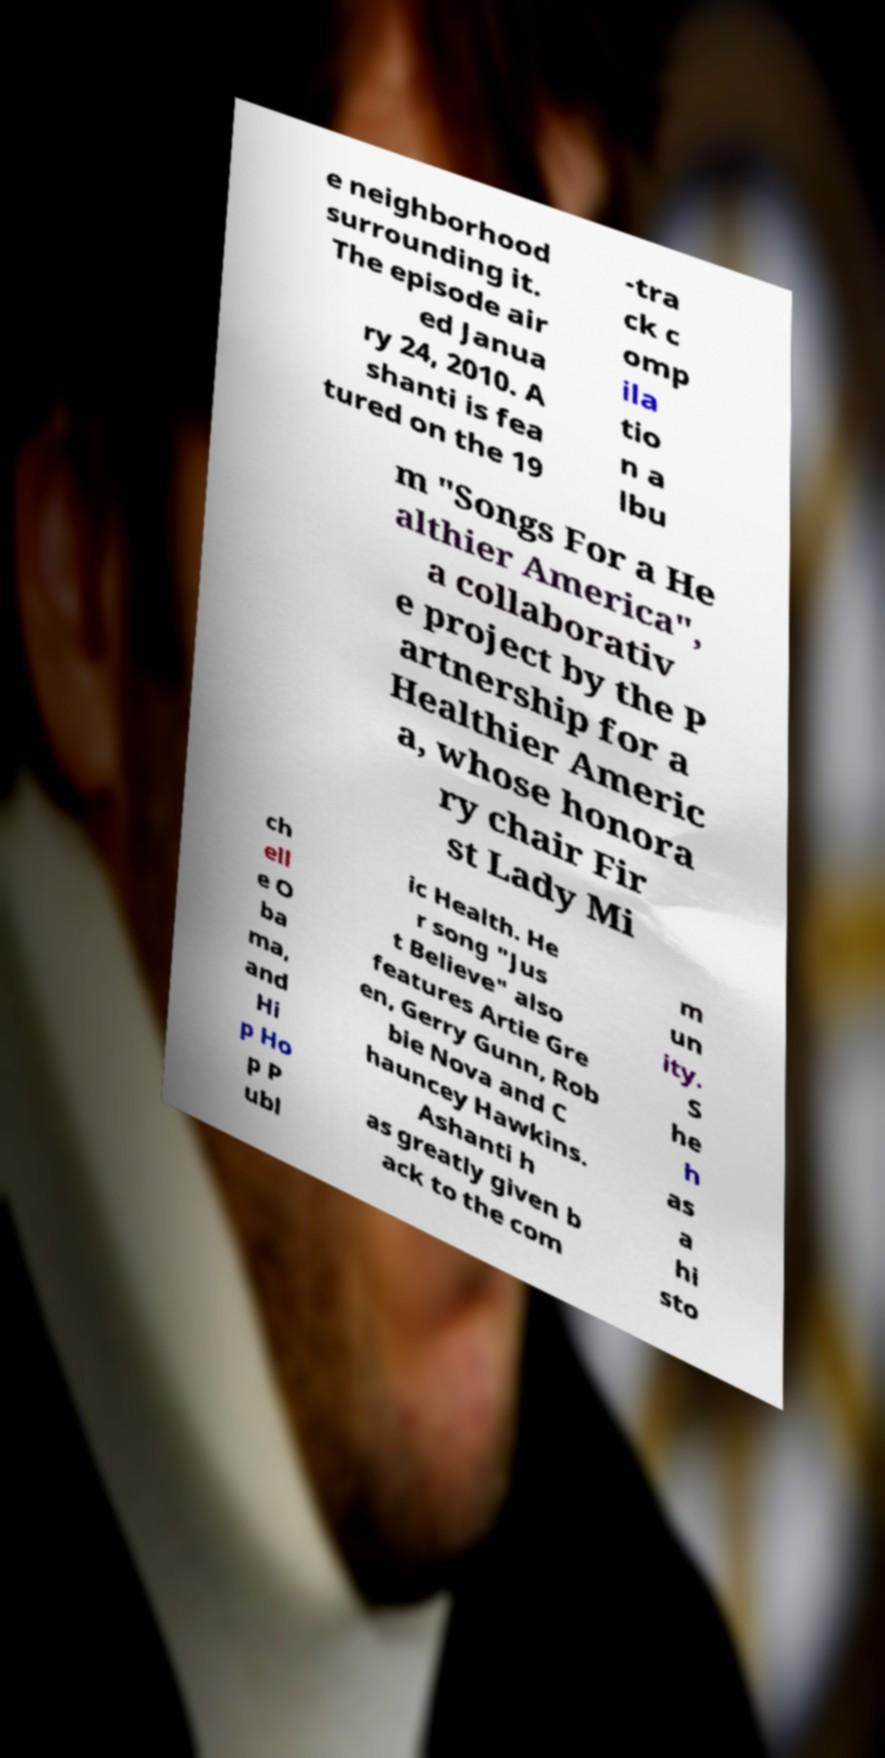Can you accurately transcribe the text from the provided image for me? e neighborhood surrounding it. The episode air ed Janua ry 24, 2010. A shanti is fea tured on the 19 -tra ck c omp ila tio n a lbu m "Songs For a He althier America", a collaborativ e project by the P artnership for a Healthier Americ a, whose honora ry chair Fir st Lady Mi ch ell e O ba ma, and Hi p Ho p P ubl ic Health. He r song "Jus t Believe" also features Artie Gre en, Gerry Gunn, Rob bie Nova and C hauncey Hawkins. Ashanti h as greatly given b ack to the com m un ity. S he h as a hi sto 